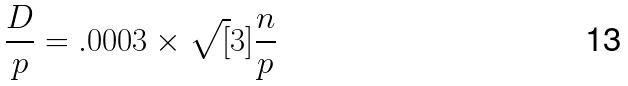<formula> <loc_0><loc_0><loc_500><loc_500>\frac { D } { p } = . 0 0 0 3 \times \sqrt { [ } 3 ] { \frac { n } { p } }</formula> 